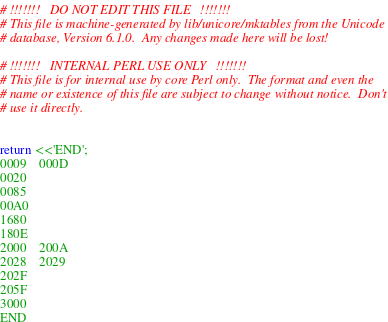<code> <loc_0><loc_0><loc_500><loc_500><_Perl_># !!!!!!!   DO NOT EDIT THIS FILE   !!!!!!!
# This file is machine-generated by lib/unicore/mktables from the Unicode
# database, Version 6.1.0.  Any changes made here will be lost!

# !!!!!!!   INTERNAL PERL USE ONLY   !!!!!!!
# This file is for internal use by core Perl only.  The format and even the
# name or existence of this file are subject to change without notice.  Don't
# use it directly.


return <<'END';
0009	000D
0020		
0085		
00A0		
1680		
180E		
2000	200A
2028	2029
202F		
205F		
3000		
END
</code> 